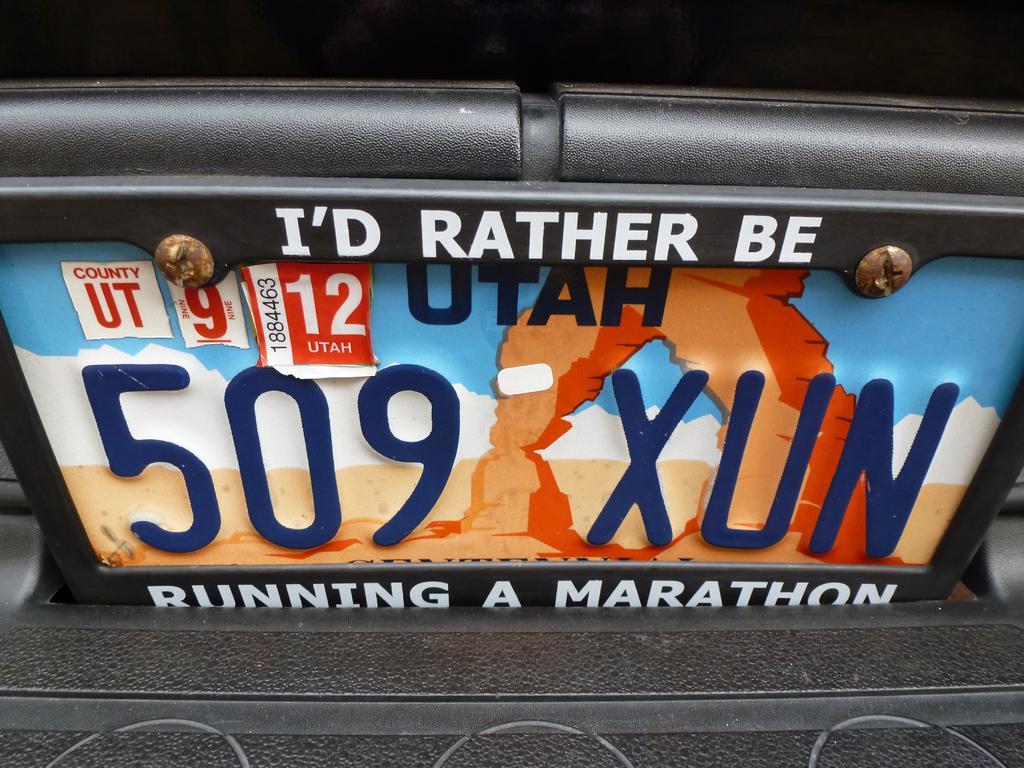<image>
Offer a succinct explanation of the picture presented. A licence plate frame says I'd Rather Be Running A Marathon. 